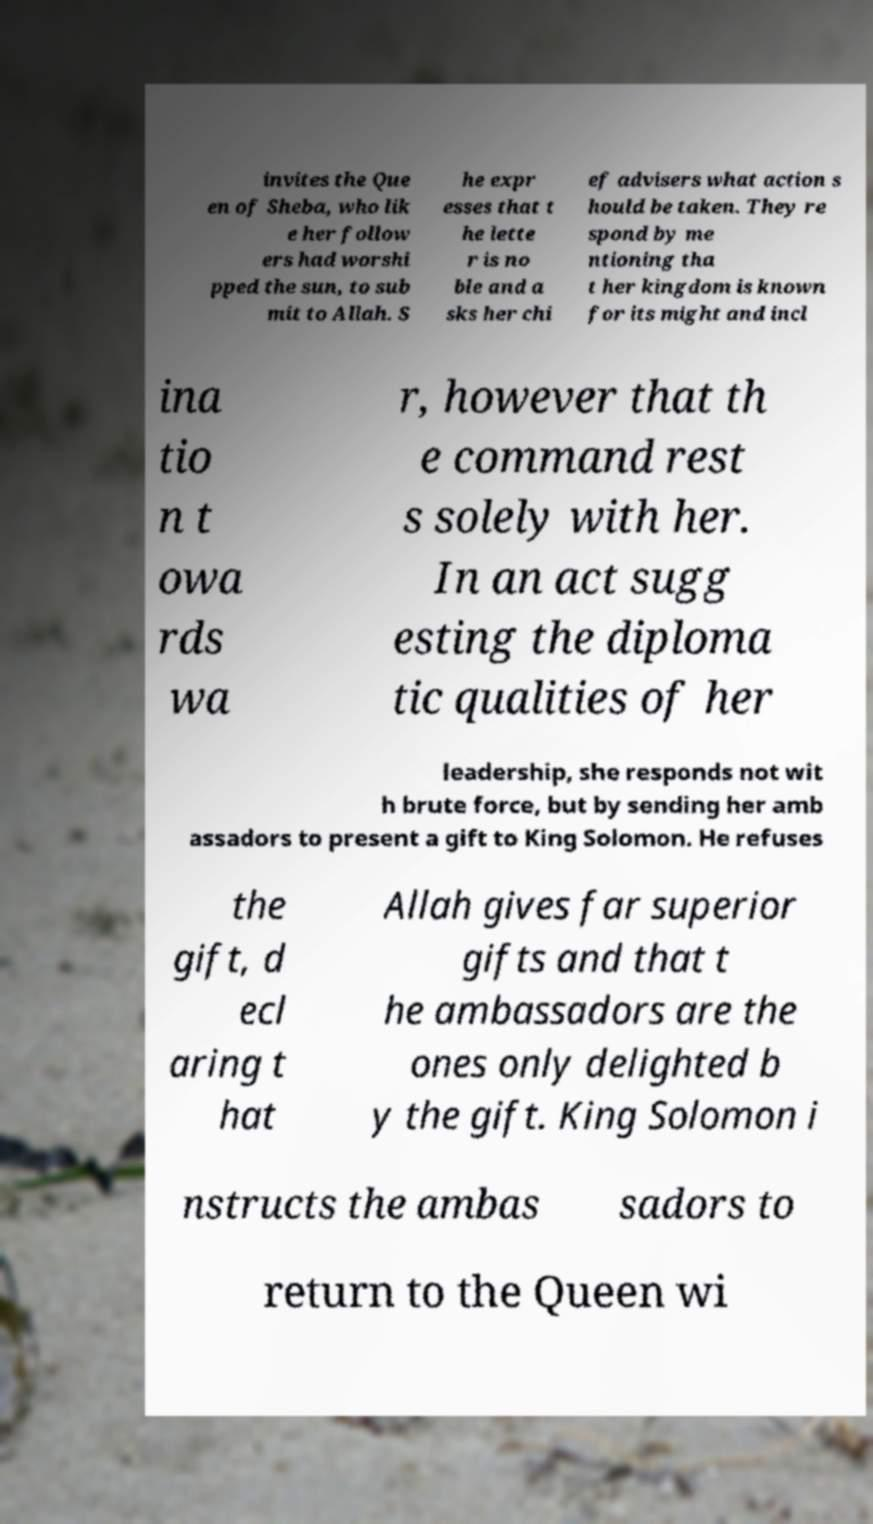For documentation purposes, I need the text within this image transcribed. Could you provide that? invites the Que en of Sheba, who lik e her follow ers had worshi pped the sun, to sub mit to Allah. S he expr esses that t he lette r is no ble and a sks her chi ef advisers what action s hould be taken. They re spond by me ntioning tha t her kingdom is known for its might and incl ina tio n t owa rds wa r, however that th e command rest s solely with her. In an act sugg esting the diploma tic qualities of her leadership, she responds not wit h brute force, but by sending her amb assadors to present a gift to King Solomon. He refuses the gift, d ecl aring t hat Allah gives far superior gifts and that t he ambassadors are the ones only delighted b y the gift. King Solomon i nstructs the ambas sadors to return to the Queen wi 